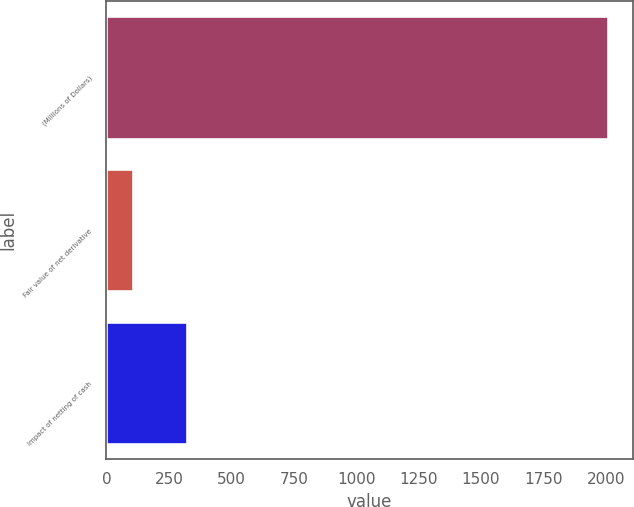Convert chart. <chart><loc_0><loc_0><loc_500><loc_500><bar_chart><fcel>(Millions of Dollars)<fcel>Fair value of net derivative<fcel>Impact of netting of cash<nl><fcel>2008<fcel>106<fcel>322<nl></chart> 